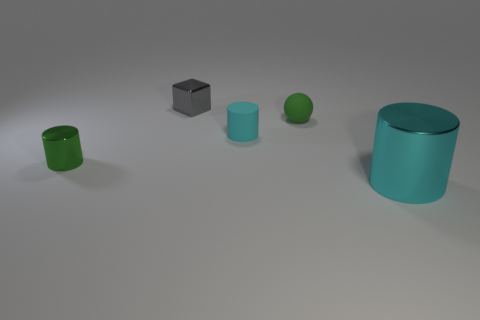There is a green thing that is the same shape as the tiny cyan thing; what size is it?
Keep it short and to the point. Small. Is there any other thing that is the same size as the cyan metallic cylinder?
Your answer should be compact. No. There is a metal thing to the right of the metal block; what is its color?
Your answer should be very brief. Cyan. What material is the tiny cylinder to the right of the metallic thing behind the green thing behind the green metallic thing?
Ensure brevity in your answer.  Rubber. There is a matte thing that is behind the cyan cylinder that is to the left of the cyan metal thing; how big is it?
Keep it short and to the point. Small. There is another big thing that is the same shape as the green shiny object; what color is it?
Make the answer very short. Cyan. How many spheres have the same color as the shiny block?
Make the answer very short. 0. Do the rubber cylinder and the cyan metal cylinder have the same size?
Give a very brief answer. No. What material is the large object?
Make the answer very short. Metal. There is a cylinder that is the same material as the big cyan object; what color is it?
Ensure brevity in your answer.  Green. 